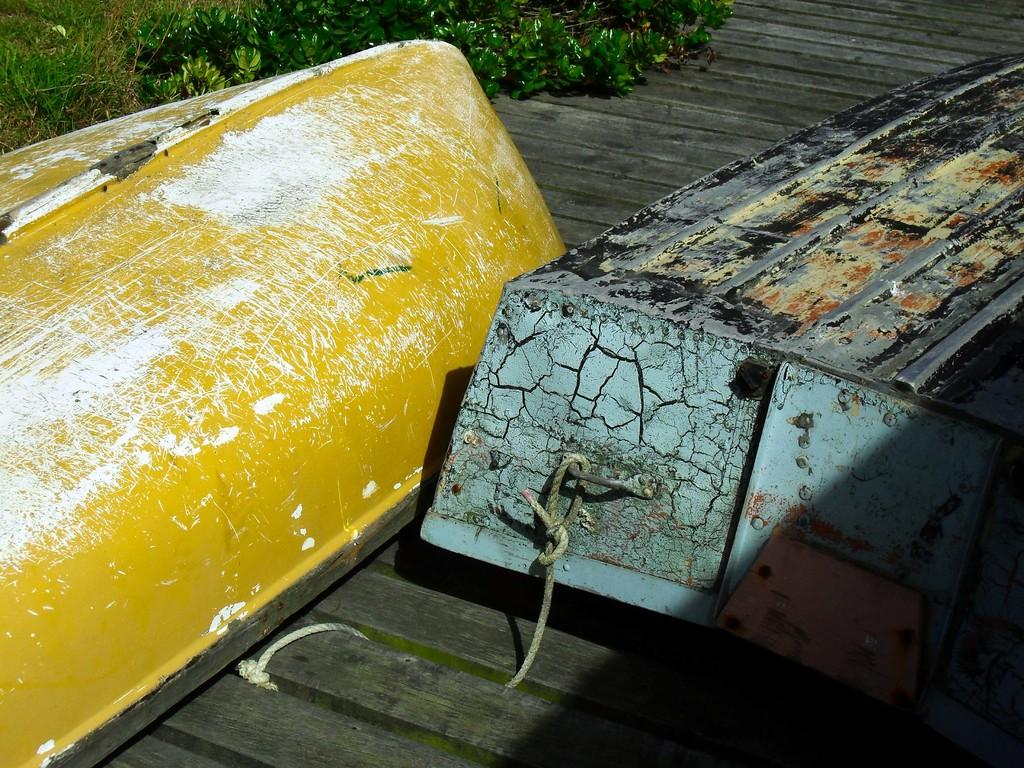What is the main subject of the image? The main subject of the image is boats. What is the surface on which the boats are placed? The boats are on a wooden surface. What type of vegetation can be seen in the background of the image? There is grass visible in the background of the image. How many pigs are on a voyage in the image? There are no pigs or any indication of a voyage present in the image. What country is the image taken in? The provided facts do not give any information about the country in which the image was taken. 